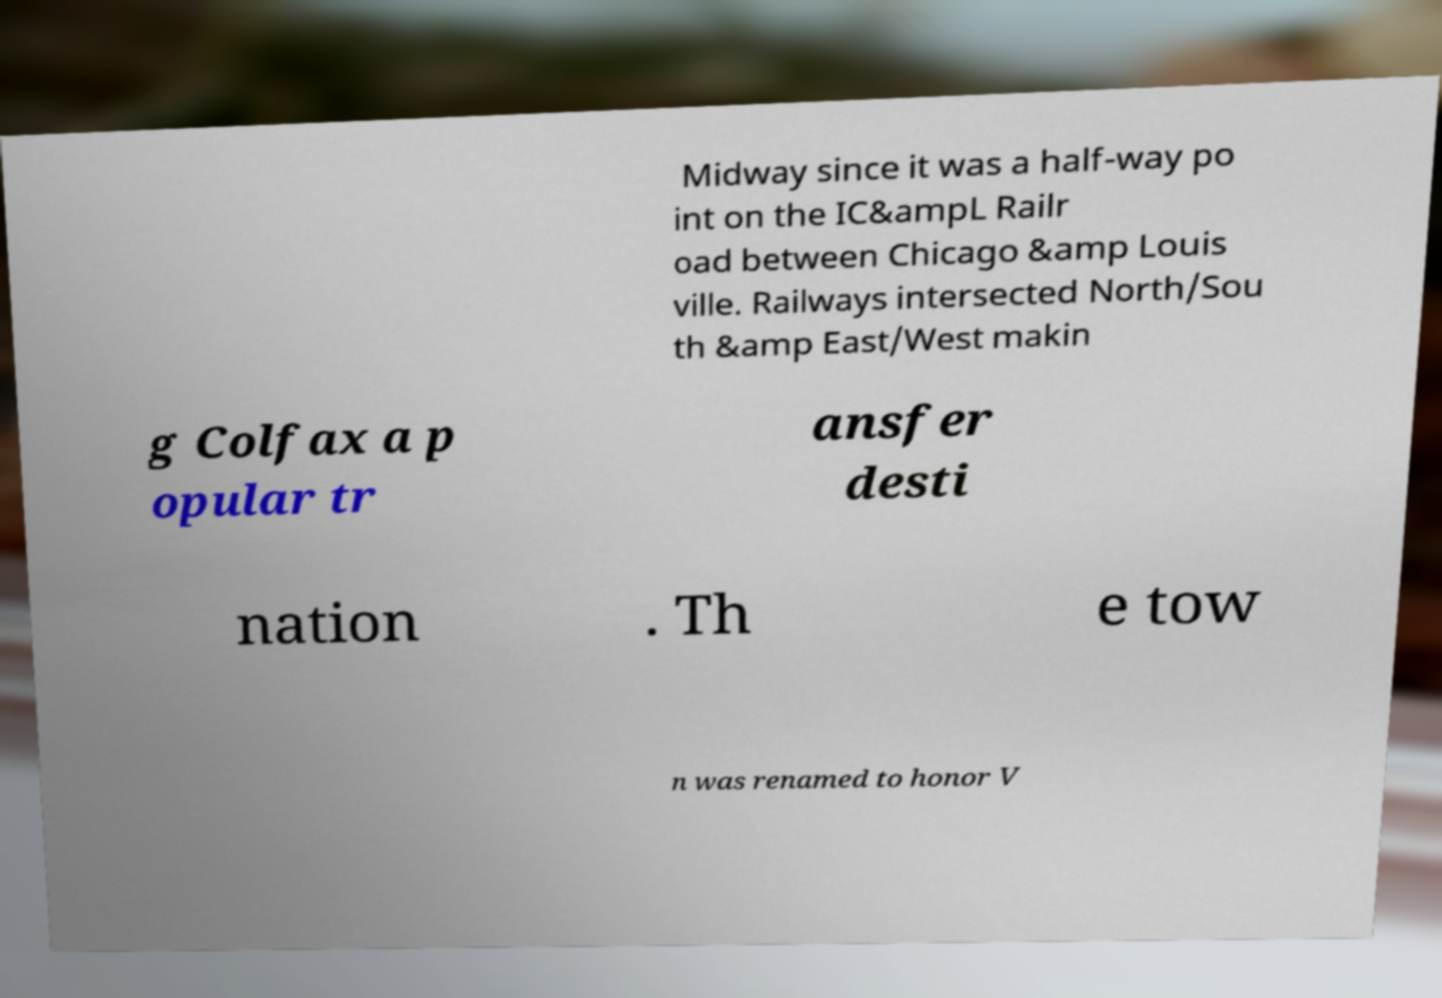For documentation purposes, I need the text within this image transcribed. Could you provide that? Midway since it was a half-way po int on the IC&ampL Railr oad between Chicago &amp Louis ville. Railways intersected North/Sou th &amp East/West makin g Colfax a p opular tr ansfer desti nation . Th e tow n was renamed to honor V 